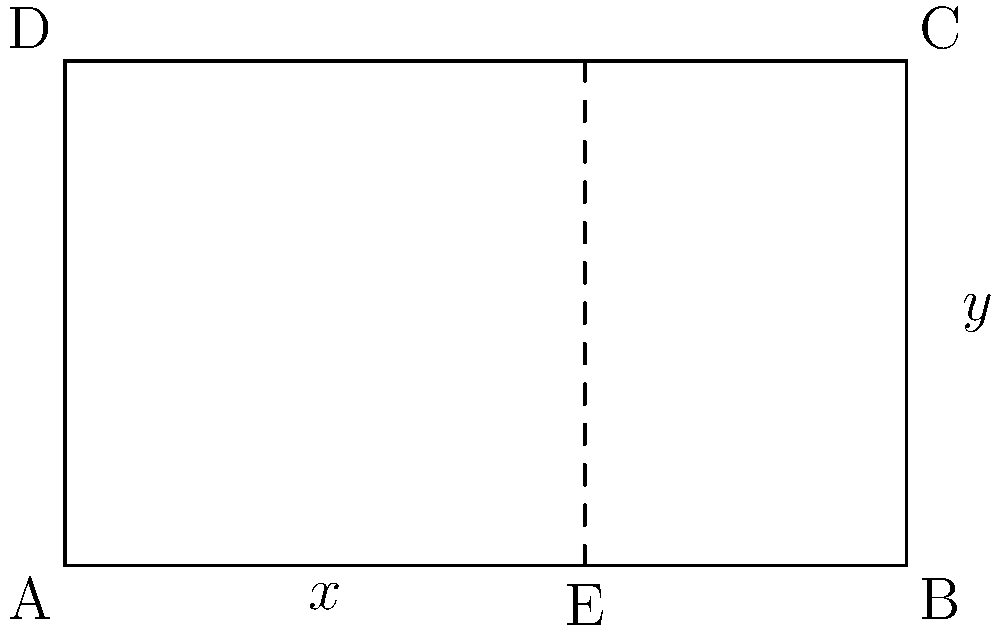A rectangular frame for a painting is designed using the golden ratio. If the width of the frame is 5 units, what is the length of the shorter section (x) when the frame is divided according to the golden ratio? Round your answer to two decimal places. To solve this problem, we'll use the properties of the golden ratio:

1. The golden ratio is approximately 1.618033...

2. In a golden rectangle, the ratio of the longer side to the shorter side is equal to the golden ratio.

3. When a golden rectangle is divided into a square and a smaller rectangle, the smaller rectangle is also a golden rectangle.

Let's apply these concepts to our frame:

1. The width of the frame is 5 units. Let's call the height y.

2. According to the golden ratio:
   $$\frac{5}{y} = \frac{y}{5-y} = \phi \approx 1.618033$$

3. We need to find x, which is the shorter section when the frame is divided according to the golden ratio. This means:
   $$\frac{5}{x} = \phi$$

4. Solving for x:
   $$x = \frac{5}{\phi} \approx \frac{5}{1.618033} \approx 3.09017$$

5. Rounding to two decimal places:
   $$x \approx 3.09$$

Therefore, the length of the shorter section (x) when the frame is divided according to the golden ratio is approximately 3.09 units.
Answer: 3.09 units 